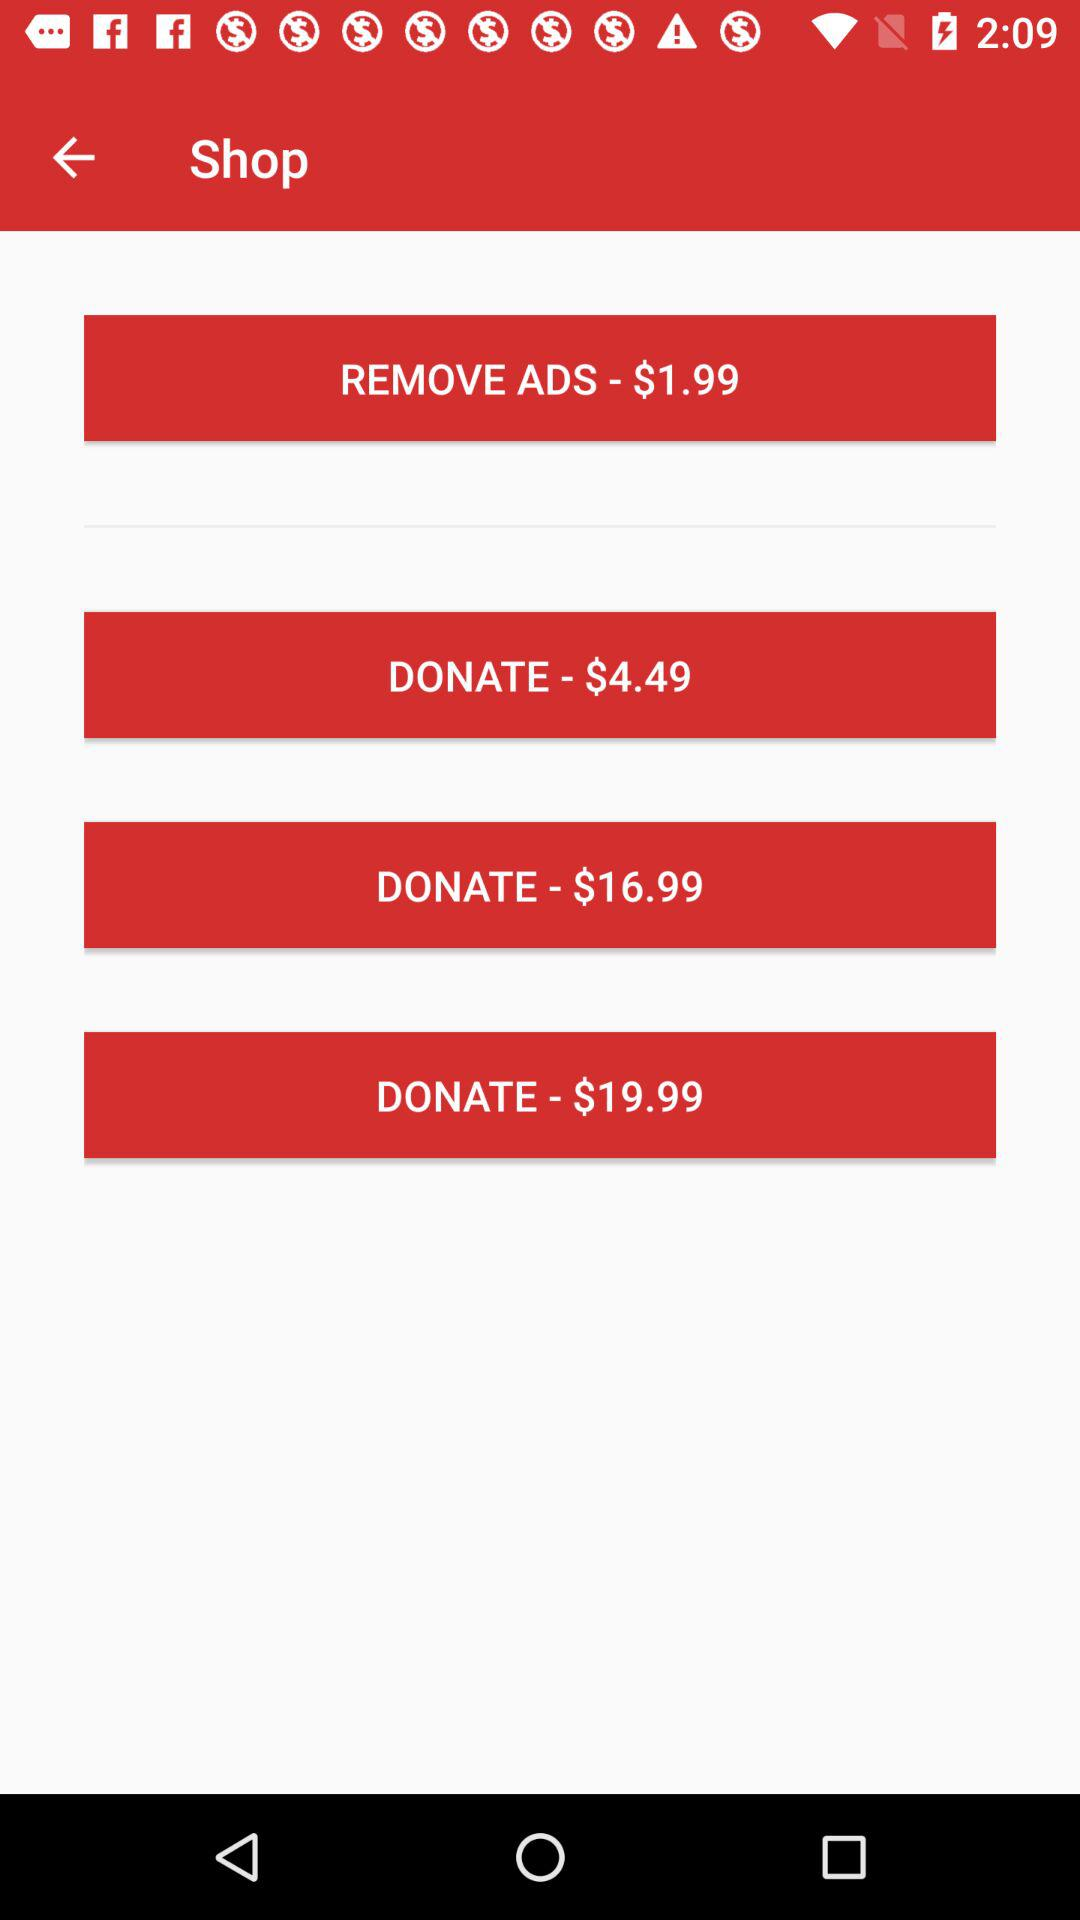What is the given price for removing ads? The given price is $1.99. 